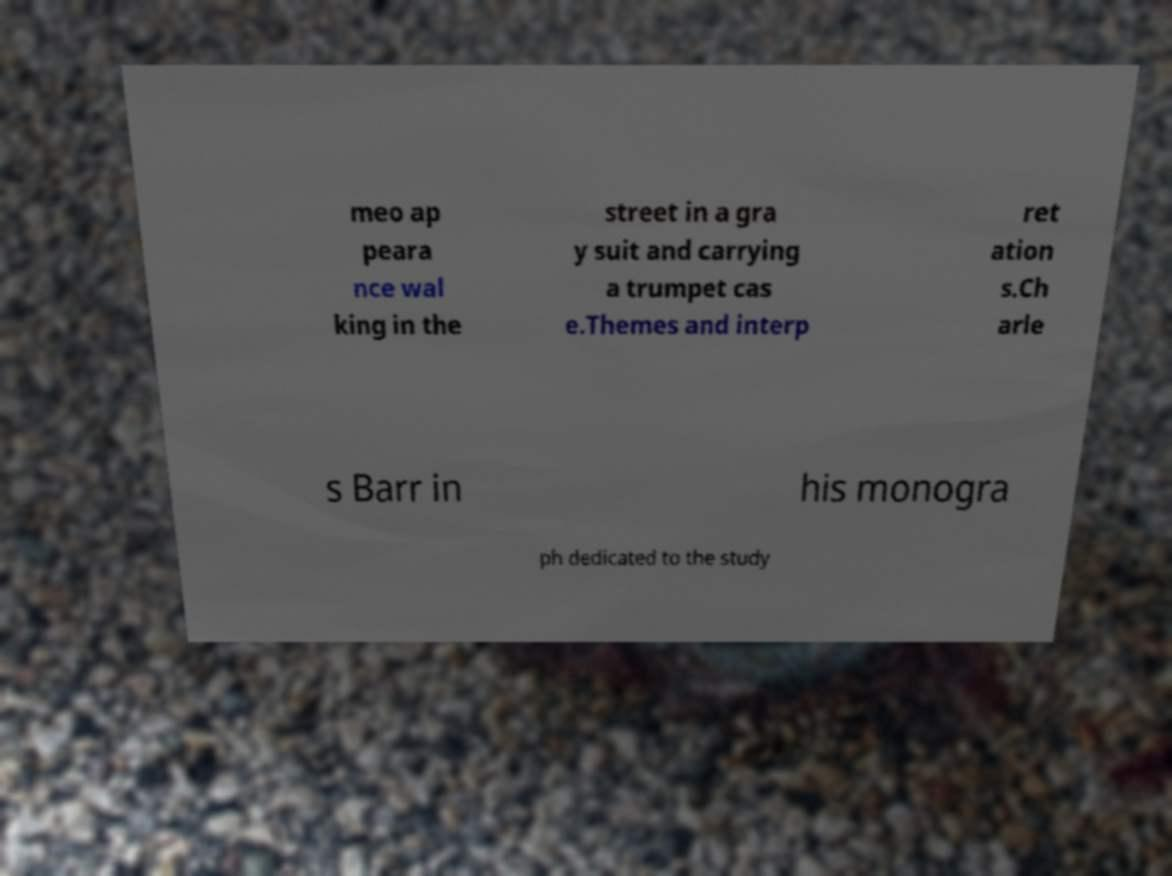Can you accurately transcribe the text from the provided image for me? meo ap peara nce wal king in the street in a gra y suit and carrying a trumpet cas e.Themes and interp ret ation s.Ch arle s Barr in his monogra ph dedicated to the study 